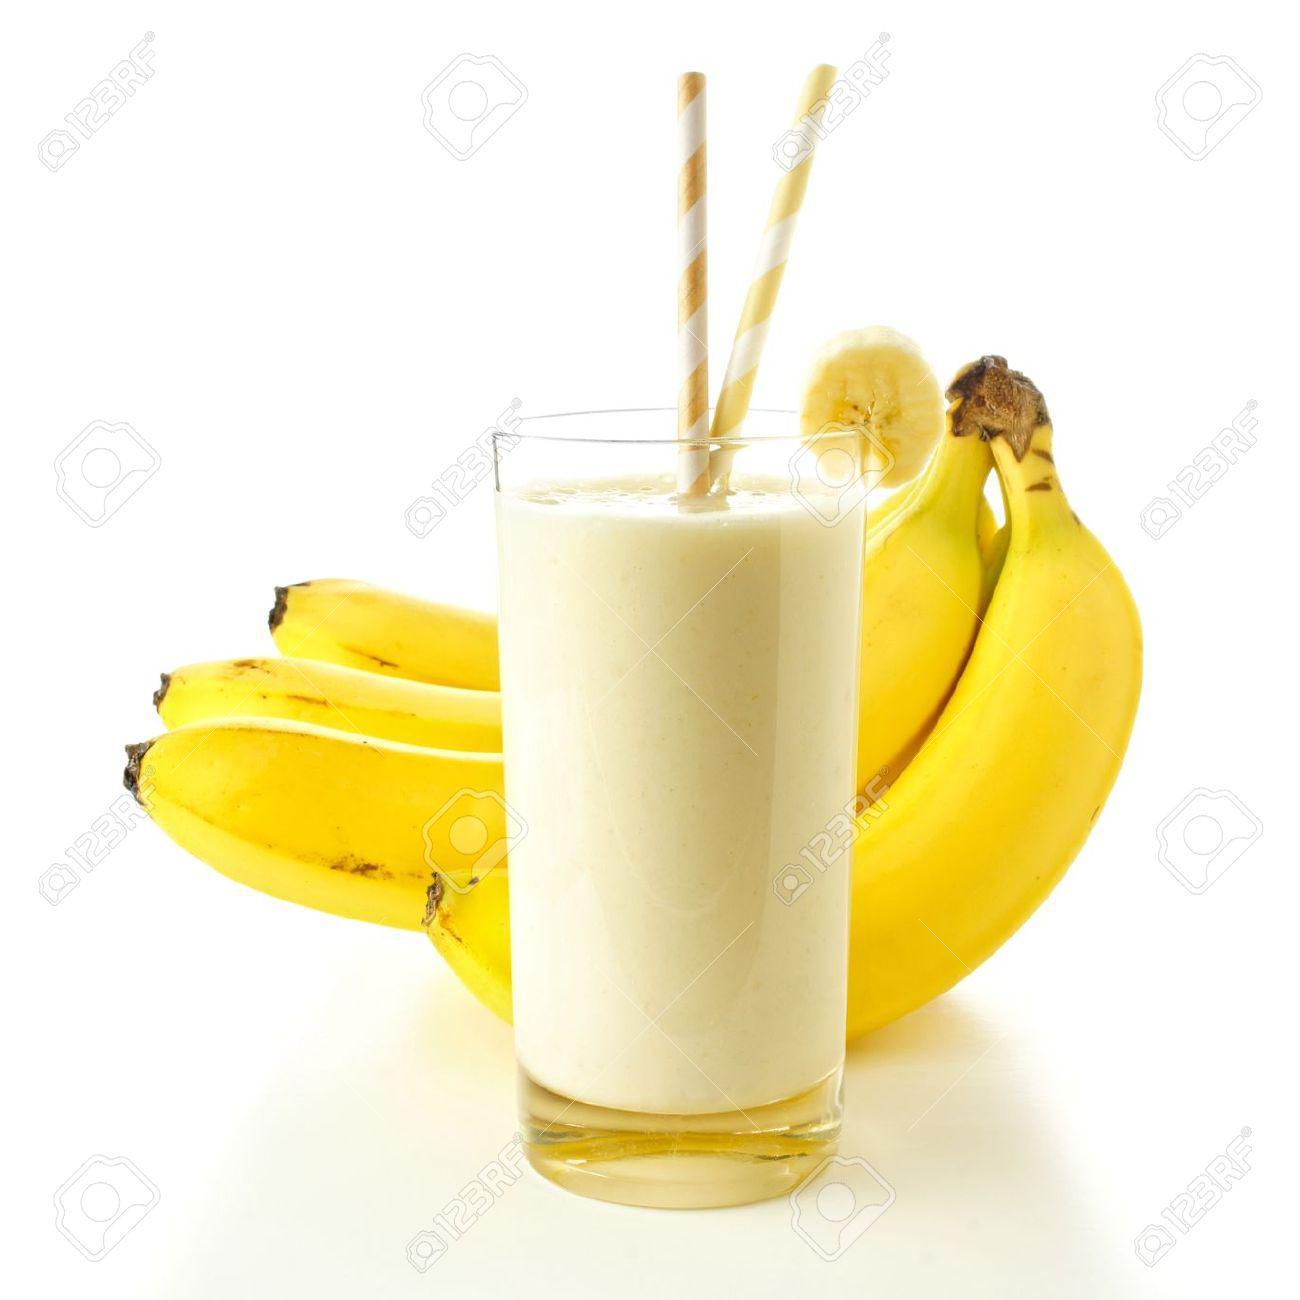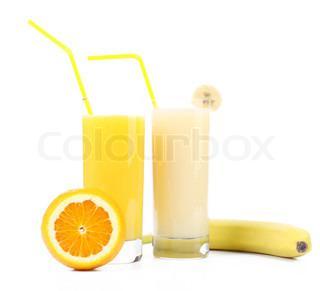The first image is the image on the left, the second image is the image on the right. For the images shown, is this caption "The right image contains no more than one orange and one banana next to two smoothies." true? Answer yes or no. Yes. The first image is the image on the left, the second image is the image on the right. Assess this claim about the two images: "A pitcher and a glass of the same beverage are behind a small bunch of bananas.". Correct or not? Answer yes or no. No. 